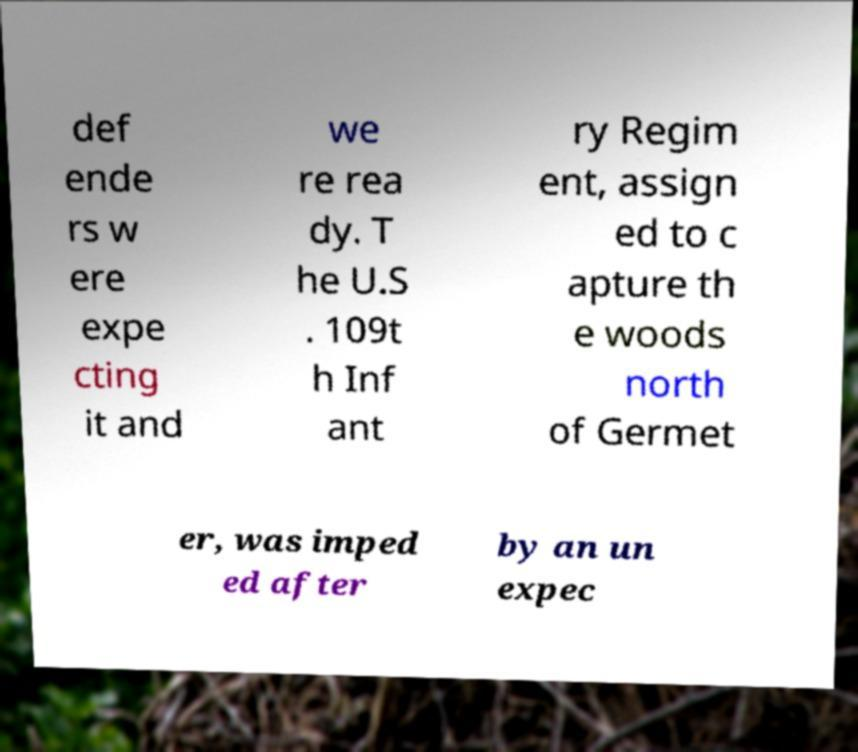There's text embedded in this image that I need extracted. Can you transcribe it verbatim? def ende rs w ere expe cting it and we re rea dy. T he U.S . 109t h Inf ant ry Regim ent, assign ed to c apture th e woods north of Germet er, was imped ed after by an un expec 